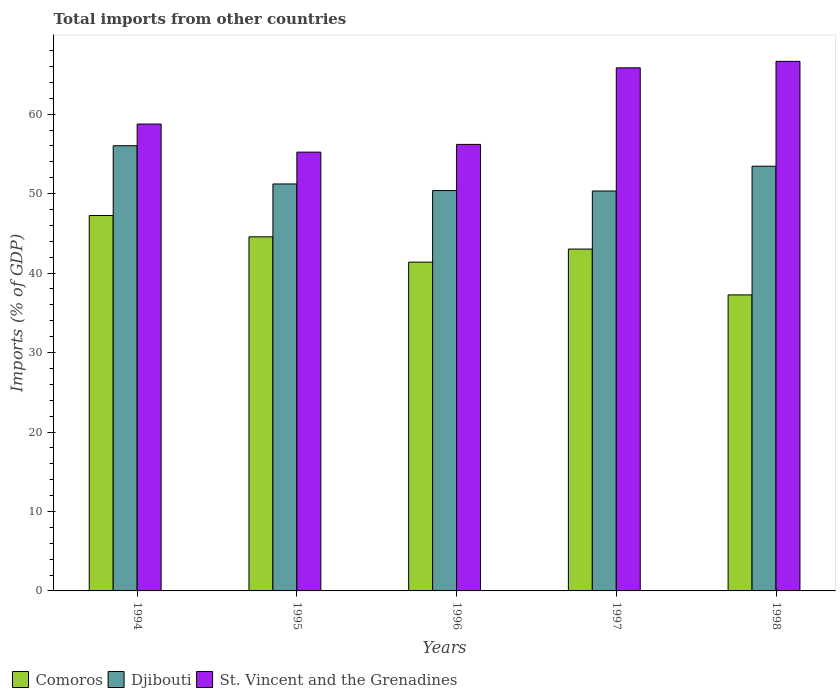How many different coloured bars are there?
Your response must be concise. 3. Are the number of bars on each tick of the X-axis equal?
Ensure brevity in your answer.  Yes. How many bars are there on the 2nd tick from the left?
Give a very brief answer. 3. In how many cases, is the number of bars for a given year not equal to the number of legend labels?
Your response must be concise. 0. What is the total imports in St. Vincent and the Grenadines in 1997?
Offer a very short reply. 65.83. Across all years, what is the maximum total imports in Djibouti?
Give a very brief answer. 56.03. Across all years, what is the minimum total imports in Djibouti?
Your answer should be very brief. 50.33. What is the total total imports in Comoros in the graph?
Your answer should be very brief. 213.48. What is the difference between the total imports in Djibouti in 1996 and that in 1997?
Provide a short and direct response. 0.05. What is the difference between the total imports in St. Vincent and the Grenadines in 1998 and the total imports in Comoros in 1994?
Your answer should be very brief. 19.4. What is the average total imports in Djibouti per year?
Your response must be concise. 52.28. In the year 1997, what is the difference between the total imports in Djibouti and total imports in St. Vincent and the Grenadines?
Provide a succinct answer. -15.5. In how many years, is the total imports in Djibouti greater than 62 %?
Offer a very short reply. 0. What is the ratio of the total imports in Djibouti in 1997 to that in 1998?
Ensure brevity in your answer.  0.94. What is the difference between the highest and the second highest total imports in Djibouti?
Give a very brief answer. 2.58. What is the difference between the highest and the lowest total imports in St. Vincent and the Grenadines?
Make the answer very short. 11.43. In how many years, is the total imports in St. Vincent and the Grenadines greater than the average total imports in St. Vincent and the Grenadines taken over all years?
Make the answer very short. 2. Is the sum of the total imports in Djibouti in 1994 and 1995 greater than the maximum total imports in St. Vincent and the Grenadines across all years?
Offer a very short reply. Yes. What does the 3rd bar from the left in 1996 represents?
Offer a very short reply. St. Vincent and the Grenadines. What does the 2nd bar from the right in 1996 represents?
Provide a short and direct response. Djibouti. Is it the case that in every year, the sum of the total imports in Djibouti and total imports in St. Vincent and the Grenadines is greater than the total imports in Comoros?
Your answer should be compact. Yes. How many bars are there?
Give a very brief answer. 15. Are all the bars in the graph horizontal?
Your answer should be very brief. No. How many years are there in the graph?
Give a very brief answer. 5. What is the difference between two consecutive major ticks on the Y-axis?
Provide a succinct answer. 10. Does the graph contain grids?
Give a very brief answer. No. How many legend labels are there?
Make the answer very short. 3. How are the legend labels stacked?
Keep it short and to the point. Horizontal. What is the title of the graph?
Provide a short and direct response. Total imports from other countries. What is the label or title of the X-axis?
Your answer should be compact. Years. What is the label or title of the Y-axis?
Your answer should be very brief. Imports (% of GDP). What is the Imports (% of GDP) in Comoros in 1994?
Provide a short and direct response. 47.25. What is the Imports (% of GDP) in Djibouti in 1994?
Keep it short and to the point. 56.03. What is the Imports (% of GDP) of St. Vincent and the Grenadines in 1994?
Offer a very short reply. 58.76. What is the Imports (% of GDP) of Comoros in 1995?
Your answer should be compact. 44.57. What is the Imports (% of GDP) in Djibouti in 1995?
Keep it short and to the point. 51.22. What is the Imports (% of GDP) of St. Vincent and the Grenadines in 1995?
Offer a terse response. 55.22. What is the Imports (% of GDP) in Comoros in 1996?
Offer a terse response. 41.38. What is the Imports (% of GDP) of Djibouti in 1996?
Keep it short and to the point. 50.39. What is the Imports (% of GDP) in St. Vincent and the Grenadines in 1996?
Provide a succinct answer. 56.2. What is the Imports (% of GDP) in Comoros in 1997?
Offer a terse response. 43.02. What is the Imports (% of GDP) of Djibouti in 1997?
Your response must be concise. 50.33. What is the Imports (% of GDP) of St. Vincent and the Grenadines in 1997?
Keep it short and to the point. 65.83. What is the Imports (% of GDP) in Comoros in 1998?
Your answer should be very brief. 37.26. What is the Imports (% of GDP) of Djibouti in 1998?
Offer a very short reply. 53.45. What is the Imports (% of GDP) in St. Vincent and the Grenadines in 1998?
Provide a short and direct response. 66.65. Across all years, what is the maximum Imports (% of GDP) of Comoros?
Your answer should be compact. 47.25. Across all years, what is the maximum Imports (% of GDP) of Djibouti?
Offer a terse response. 56.03. Across all years, what is the maximum Imports (% of GDP) of St. Vincent and the Grenadines?
Offer a terse response. 66.65. Across all years, what is the minimum Imports (% of GDP) of Comoros?
Ensure brevity in your answer.  37.26. Across all years, what is the minimum Imports (% of GDP) of Djibouti?
Your answer should be compact. 50.33. Across all years, what is the minimum Imports (% of GDP) in St. Vincent and the Grenadines?
Provide a succinct answer. 55.22. What is the total Imports (% of GDP) of Comoros in the graph?
Give a very brief answer. 213.48. What is the total Imports (% of GDP) of Djibouti in the graph?
Provide a succinct answer. 261.42. What is the total Imports (% of GDP) in St. Vincent and the Grenadines in the graph?
Make the answer very short. 302.66. What is the difference between the Imports (% of GDP) of Comoros in 1994 and that in 1995?
Ensure brevity in your answer.  2.68. What is the difference between the Imports (% of GDP) in Djibouti in 1994 and that in 1995?
Your answer should be compact. 4.81. What is the difference between the Imports (% of GDP) in St. Vincent and the Grenadines in 1994 and that in 1995?
Offer a terse response. 3.54. What is the difference between the Imports (% of GDP) of Comoros in 1994 and that in 1996?
Offer a very short reply. 5.87. What is the difference between the Imports (% of GDP) of Djibouti in 1994 and that in 1996?
Ensure brevity in your answer.  5.64. What is the difference between the Imports (% of GDP) in St. Vincent and the Grenadines in 1994 and that in 1996?
Make the answer very short. 2.56. What is the difference between the Imports (% of GDP) in Comoros in 1994 and that in 1997?
Offer a very short reply. 4.22. What is the difference between the Imports (% of GDP) of Djibouti in 1994 and that in 1997?
Provide a succinct answer. 5.7. What is the difference between the Imports (% of GDP) of St. Vincent and the Grenadines in 1994 and that in 1997?
Make the answer very short. -7.07. What is the difference between the Imports (% of GDP) in Comoros in 1994 and that in 1998?
Ensure brevity in your answer.  9.99. What is the difference between the Imports (% of GDP) of Djibouti in 1994 and that in 1998?
Offer a very short reply. 2.58. What is the difference between the Imports (% of GDP) of St. Vincent and the Grenadines in 1994 and that in 1998?
Your answer should be compact. -7.89. What is the difference between the Imports (% of GDP) in Comoros in 1995 and that in 1996?
Your response must be concise. 3.19. What is the difference between the Imports (% of GDP) in Djibouti in 1995 and that in 1996?
Provide a short and direct response. 0.83. What is the difference between the Imports (% of GDP) of St. Vincent and the Grenadines in 1995 and that in 1996?
Offer a very short reply. -0.97. What is the difference between the Imports (% of GDP) of Comoros in 1995 and that in 1997?
Provide a succinct answer. 1.54. What is the difference between the Imports (% of GDP) in Djibouti in 1995 and that in 1997?
Your response must be concise. 0.89. What is the difference between the Imports (% of GDP) of St. Vincent and the Grenadines in 1995 and that in 1997?
Your response must be concise. -10.61. What is the difference between the Imports (% of GDP) of Comoros in 1995 and that in 1998?
Your response must be concise. 7.31. What is the difference between the Imports (% of GDP) in Djibouti in 1995 and that in 1998?
Your response must be concise. -2.24. What is the difference between the Imports (% of GDP) of St. Vincent and the Grenadines in 1995 and that in 1998?
Your response must be concise. -11.43. What is the difference between the Imports (% of GDP) in Comoros in 1996 and that in 1997?
Provide a short and direct response. -1.64. What is the difference between the Imports (% of GDP) of Djibouti in 1996 and that in 1997?
Your answer should be compact. 0.05. What is the difference between the Imports (% of GDP) of St. Vincent and the Grenadines in 1996 and that in 1997?
Keep it short and to the point. -9.64. What is the difference between the Imports (% of GDP) of Comoros in 1996 and that in 1998?
Keep it short and to the point. 4.12. What is the difference between the Imports (% of GDP) of Djibouti in 1996 and that in 1998?
Offer a terse response. -3.07. What is the difference between the Imports (% of GDP) of St. Vincent and the Grenadines in 1996 and that in 1998?
Provide a succinct answer. -10.45. What is the difference between the Imports (% of GDP) in Comoros in 1997 and that in 1998?
Make the answer very short. 5.77. What is the difference between the Imports (% of GDP) in Djibouti in 1997 and that in 1998?
Keep it short and to the point. -3.12. What is the difference between the Imports (% of GDP) of St. Vincent and the Grenadines in 1997 and that in 1998?
Provide a succinct answer. -0.82. What is the difference between the Imports (% of GDP) in Comoros in 1994 and the Imports (% of GDP) in Djibouti in 1995?
Offer a very short reply. -3.97. What is the difference between the Imports (% of GDP) in Comoros in 1994 and the Imports (% of GDP) in St. Vincent and the Grenadines in 1995?
Provide a succinct answer. -7.98. What is the difference between the Imports (% of GDP) in Djibouti in 1994 and the Imports (% of GDP) in St. Vincent and the Grenadines in 1995?
Your response must be concise. 0.81. What is the difference between the Imports (% of GDP) in Comoros in 1994 and the Imports (% of GDP) in Djibouti in 1996?
Ensure brevity in your answer.  -3.14. What is the difference between the Imports (% of GDP) of Comoros in 1994 and the Imports (% of GDP) of St. Vincent and the Grenadines in 1996?
Give a very brief answer. -8.95. What is the difference between the Imports (% of GDP) of Djibouti in 1994 and the Imports (% of GDP) of St. Vincent and the Grenadines in 1996?
Provide a short and direct response. -0.17. What is the difference between the Imports (% of GDP) in Comoros in 1994 and the Imports (% of GDP) in Djibouti in 1997?
Your response must be concise. -3.08. What is the difference between the Imports (% of GDP) of Comoros in 1994 and the Imports (% of GDP) of St. Vincent and the Grenadines in 1997?
Offer a terse response. -18.59. What is the difference between the Imports (% of GDP) of Djibouti in 1994 and the Imports (% of GDP) of St. Vincent and the Grenadines in 1997?
Provide a short and direct response. -9.8. What is the difference between the Imports (% of GDP) of Comoros in 1994 and the Imports (% of GDP) of Djibouti in 1998?
Provide a succinct answer. -6.2. What is the difference between the Imports (% of GDP) of Comoros in 1994 and the Imports (% of GDP) of St. Vincent and the Grenadines in 1998?
Make the answer very short. -19.4. What is the difference between the Imports (% of GDP) in Djibouti in 1994 and the Imports (% of GDP) in St. Vincent and the Grenadines in 1998?
Offer a terse response. -10.62. What is the difference between the Imports (% of GDP) in Comoros in 1995 and the Imports (% of GDP) in Djibouti in 1996?
Make the answer very short. -5.82. What is the difference between the Imports (% of GDP) in Comoros in 1995 and the Imports (% of GDP) in St. Vincent and the Grenadines in 1996?
Your answer should be very brief. -11.63. What is the difference between the Imports (% of GDP) of Djibouti in 1995 and the Imports (% of GDP) of St. Vincent and the Grenadines in 1996?
Offer a terse response. -4.98. What is the difference between the Imports (% of GDP) of Comoros in 1995 and the Imports (% of GDP) of Djibouti in 1997?
Provide a succinct answer. -5.76. What is the difference between the Imports (% of GDP) in Comoros in 1995 and the Imports (% of GDP) in St. Vincent and the Grenadines in 1997?
Provide a short and direct response. -21.27. What is the difference between the Imports (% of GDP) of Djibouti in 1995 and the Imports (% of GDP) of St. Vincent and the Grenadines in 1997?
Offer a terse response. -14.62. What is the difference between the Imports (% of GDP) in Comoros in 1995 and the Imports (% of GDP) in Djibouti in 1998?
Your response must be concise. -8.89. What is the difference between the Imports (% of GDP) of Comoros in 1995 and the Imports (% of GDP) of St. Vincent and the Grenadines in 1998?
Your response must be concise. -22.08. What is the difference between the Imports (% of GDP) of Djibouti in 1995 and the Imports (% of GDP) of St. Vincent and the Grenadines in 1998?
Make the answer very short. -15.43. What is the difference between the Imports (% of GDP) in Comoros in 1996 and the Imports (% of GDP) in Djibouti in 1997?
Ensure brevity in your answer.  -8.95. What is the difference between the Imports (% of GDP) in Comoros in 1996 and the Imports (% of GDP) in St. Vincent and the Grenadines in 1997?
Provide a short and direct response. -24.45. What is the difference between the Imports (% of GDP) in Djibouti in 1996 and the Imports (% of GDP) in St. Vincent and the Grenadines in 1997?
Keep it short and to the point. -15.45. What is the difference between the Imports (% of GDP) of Comoros in 1996 and the Imports (% of GDP) of Djibouti in 1998?
Provide a short and direct response. -12.07. What is the difference between the Imports (% of GDP) in Comoros in 1996 and the Imports (% of GDP) in St. Vincent and the Grenadines in 1998?
Provide a short and direct response. -25.27. What is the difference between the Imports (% of GDP) in Djibouti in 1996 and the Imports (% of GDP) in St. Vincent and the Grenadines in 1998?
Give a very brief answer. -16.26. What is the difference between the Imports (% of GDP) in Comoros in 1997 and the Imports (% of GDP) in Djibouti in 1998?
Your answer should be compact. -10.43. What is the difference between the Imports (% of GDP) in Comoros in 1997 and the Imports (% of GDP) in St. Vincent and the Grenadines in 1998?
Your answer should be compact. -23.63. What is the difference between the Imports (% of GDP) of Djibouti in 1997 and the Imports (% of GDP) of St. Vincent and the Grenadines in 1998?
Offer a terse response. -16.32. What is the average Imports (% of GDP) of Comoros per year?
Your response must be concise. 42.7. What is the average Imports (% of GDP) in Djibouti per year?
Offer a terse response. 52.28. What is the average Imports (% of GDP) of St. Vincent and the Grenadines per year?
Make the answer very short. 60.53. In the year 1994, what is the difference between the Imports (% of GDP) in Comoros and Imports (% of GDP) in Djibouti?
Offer a terse response. -8.78. In the year 1994, what is the difference between the Imports (% of GDP) of Comoros and Imports (% of GDP) of St. Vincent and the Grenadines?
Give a very brief answer. -11.51. In the year 1994, what is the difference between the Imports (% of GDP) in Djibouti and Imports (% of GDP) in St. Vincent and the Grenadines?
Provide a short and direct response. -2.73. In the year 1995, what is the difference between the Imports (% of GDP) of Comoros and Imports (% of GDP) of Djibouti?
Offer a very short reply. -6.65. In the year 1995, what is the difference between the Imports (% of GDP) in Comoros and Imports (% of GDP) in St. Vincent and the Grenadines?
Provide a succinct answer. -10.66. In the year 1995, what is the difference between the Imports (% of GDP) of Djibouti and Imports (% of GDP) of St. Vincent and the Grenadines?
Your response must be concise. -4.01. In the year 1996, what is the difference between the Imports (% of GDP) of Comoros and Imports (% of GDP) of Djibouti?
Ensure brevity in your answer.  -9. In the year 1996, what is the difference between the Imports (% of GDP) in Comoros and Imports (% of GDP) in St. Vincent and the Grenadines?
Provide a short and direct response. -14.82. In the year 1996, what is the difference between the Imports (% of GDP) of Djibouti and Imports (% of GDP) of St. Vincent and the Grenadines?
Offer a very short reply. -5.81. In the year 1997, what is the difference between the Imports (% of GDP) of Comoros and Imports (% of GDP) of Djibouti?
Offer a very short reply. -7.31. In the year 1997, what is the difference between the Imports (% of GDP) in Comoros and Imports (% of GDP) in St. Vincent and the Grenadines?
Give a very brief answer. -22.81. In the year 1997, what is the difference between the Imports (% of GDP) of Djibouti and Imports (% of GDP) of St. Vincent and the Grenadines?
Offer a very short reply. -15.5. In the year 1998, what is the difference between the Imports (% of GDP) of Comoros and Imports (% of GDP) of Djibouti?
Provide a short and direct response. -16.2. In the year 1998, what is the difference between the Imports (% of GDP) in Comoros and Imports (% of GDP) in St. Vincent and the Grenadines?
Offer a terse response. -29.39. In the year 1998, what is the difference between the Imports (% of GDP) in Djibouti and Imports (% of GDP) in St. Vincent and the Grenadines?
Offer a very short reply. -13.2. What is the ratio of the Imports (% of GDP) of Comoros in 1994 to that in 1995?
Make the answer very short. 1.06. What is the ratio of the Imports (% of GDP) in Djibouti in 1994 to that in 1995?
Make the answer very short. 1.09. What is the ratio of the Imports (% of GDP) of St. Vincent and the Grenadines in 1994 to that in 1995?
Provide a short and direct response. 1.06. What is the ratio of the Imports (% of GDP) of Comoros in 1994 to that in 1996?
Your answer should be compact. 1.14. What is the ratio of the Imports (% of GDP) of Djibouti in 1994 to that in 1996?
Provide a short and direct response. 1.11. What is the ratio of the Imports (% of GDP) in St. Vincent and the Grenadines in 1994 to that in 1996?
Provide a succinct answer. 1.05. What is the ratio of the Imports (% of GDP) of Comoros in 1994 to that in 1997?
Offer a terse response. 1.1. What is the ratio of the Imports (% of GDP) of Djibouti in 1994 to that in 1997?
Ensure brevity in your answer.  1.11. What is the ratio of the Imports (% of GDP) of St. Vincent and the Grenadines in 1994 to that in 1997?
Make the answer very short. 0.89. What is the ratio of the Imports (% of GDP) of Comoros in 1994 to that in 1998?
Your response must be concise. 1.27. What is the ratio of the Imports (% of GDP) of Djibouti in 1994 to that in 1998?
Make the answer very short. 1.05. What is the ratio of the Imports (% of GDP) in St. Vincent and the Grenadines in 1994 to that in 1998?
Give a very brief answer. 0.88. What is the ratio of the Imports (% of GDP) in Comoros in 1995 to that in 1996?
Provide a short and direct response. 1.08. What is the ratio of the Imports (% of GDP) of Djibouti in 1995 to that in 1996?
Give a very brief answer. 1.02. What is the ratio of the Imports (% of GDP) in St. Vincent and the Grenadines in 1995 to that in 1996?
Ensure brevity in your answer.  0.98. What is the ratio of the Imports (% of GDP) in Comoros in 1995 to that in 1997?
Your answer should be compact. 1.04. What is the ratio of the Imports (% of GDP) of Djibouti in 1995 to that in 1997?
Offer a very short reply. 1.02. What is the ratio of the Imports (% of GDP) of St. Vincent and the Grenadines in 1995 to that in 1997?
Give a very brief answer. 0.84. What is the ratio of the Imports (% of GDP) in Comoros in 1995 to that in 1998?
Your response must be concise. 1.2. What is the ratio of the Imports (% of GDP) in Djibouti in 1995 to that in 1998?
Make the answer very short. 0.96. What is the ratio of the Imports (% of GDP) in St. Vincent and the Grenadines in 1995 to that in 1998?
Offer a terse response. 0.83. What is the ratio of the Imports (% of GDP) in Comoros in 1996 to that in 1997?
Provide a short and direct response. 0.96. What is the ratio of the Imports (% of GDP) of St. Vincent and the Grenadines in 1996 to that in 1997?
Offer a terse response. 0.85. What is the ratio of the Imports (% of GDP) in Comoros in 1996 to that in 1998?
Keep it short and to the point. 1.11. What is the ratio of the Imports (% of GDP) of Djibouti in 1996 to that in 1998?
Make the answer very short. 0.94. What is the ratio of the Imports (% of GDP) of St. Vincent and the Grenadines in 1996 to that in 1998?
Keep it short and to the point. 0.84. What is the ratio of the Imports (% of GDP) of Comoros in 1997 to that in 1998?
Make the answer very short. 1.15. What is the ratio of the Imports (% of GDP) of Djibouti in 1997 to that in 1998?
Provide a succinct answer. 0.94. What is the difference between the highest and the second highest Imports (% of GDP) of Comoros?
Give a very brief answer. 2.68. What is the difference between the highest and the second highest Imports (% of GDP) of Djibouti?
Give a very brief answer. 2.58. What is the difference between the highest and the second highest Imports (% of GDP) of St. Vincent and the Grenadines?
Ensure brevity in your answer.  0.82. What is the difference between the highest and the lowest Imports (% of GDP) of Comoros?
Offer a very short reply. 9.99. What is the difference between the highest and the lowest Imports (% of GDP) in Djibouti?
Offer a very short reply. 5.7. What is the difference between the highest and the lowest Imports (% of GDP) in St. Vincent and the Grenadines?
Give a very brief answer. 11.43. 